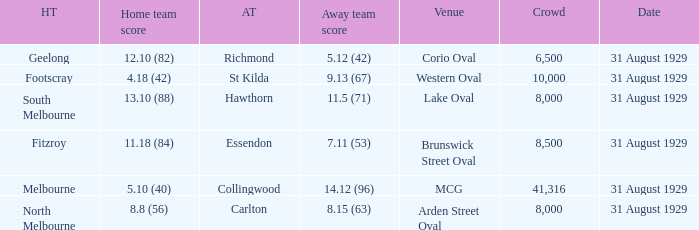What was the away team when the game was at corio oval? Richmond. 